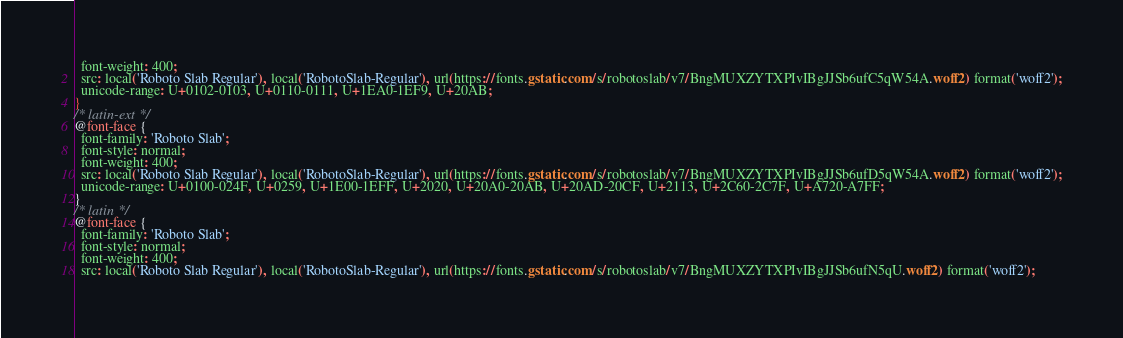<code> <loc_0><loc_0><loc_500><loc_500><_CSS_>  font-weight: 400;
  src: local('Roboto Slab Regular'), local('RobotoSlab-Regular'), url(https://fonts.gstatic.com/s/robotoslab/v7/BngMUXZYTXPIvIBgJJSb6ufC5qW54A.woff2) format('woff2');
  unicode-range: U+0102-0103, U+0110-0111, U+1EA0-1EF9, U+20AB;
}
/* latin-ext */
@font-face {
  font-family: 'Roboto Slab';
  font-style: normal;
  font-weight: 400;
  src: local('Roboto Slab Regular'), local('RobotoSlab-Regular'), url(https://fonts.gstatic.com/s/robotoslab/v7/BngMUXZYTXPIvIBgJJSb6ufD5qW54A.woff2) format('woff2');
  unicode-range: U+0100-024F, U+0259, U+1E00-1EFF, U+2020, U+20A0-20AB, U+20AD-20CF, U+2113, U+2C60-2C7F, U+A720-A7FF;
}
/* latin */
@font-face {
  font-family: 'Roboto Slab';
  font-style: normal;
  font-weight: 400;
  src: local('Roboto Slab Regular'), local('RobotoSlab-Regular'), url(https://fonts.gstatic.com/s/robotoslab/v7/BngMUXZYTXPIvIBgJJSb6ufN5qU.woff2) format('woff2');</code> 